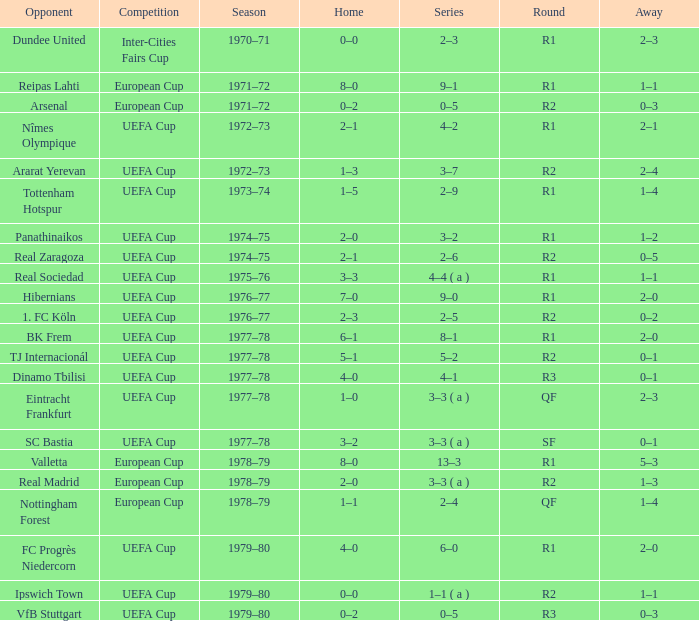Which Home has a Round of r1, and an Opponent of dundee united? 0–0. 